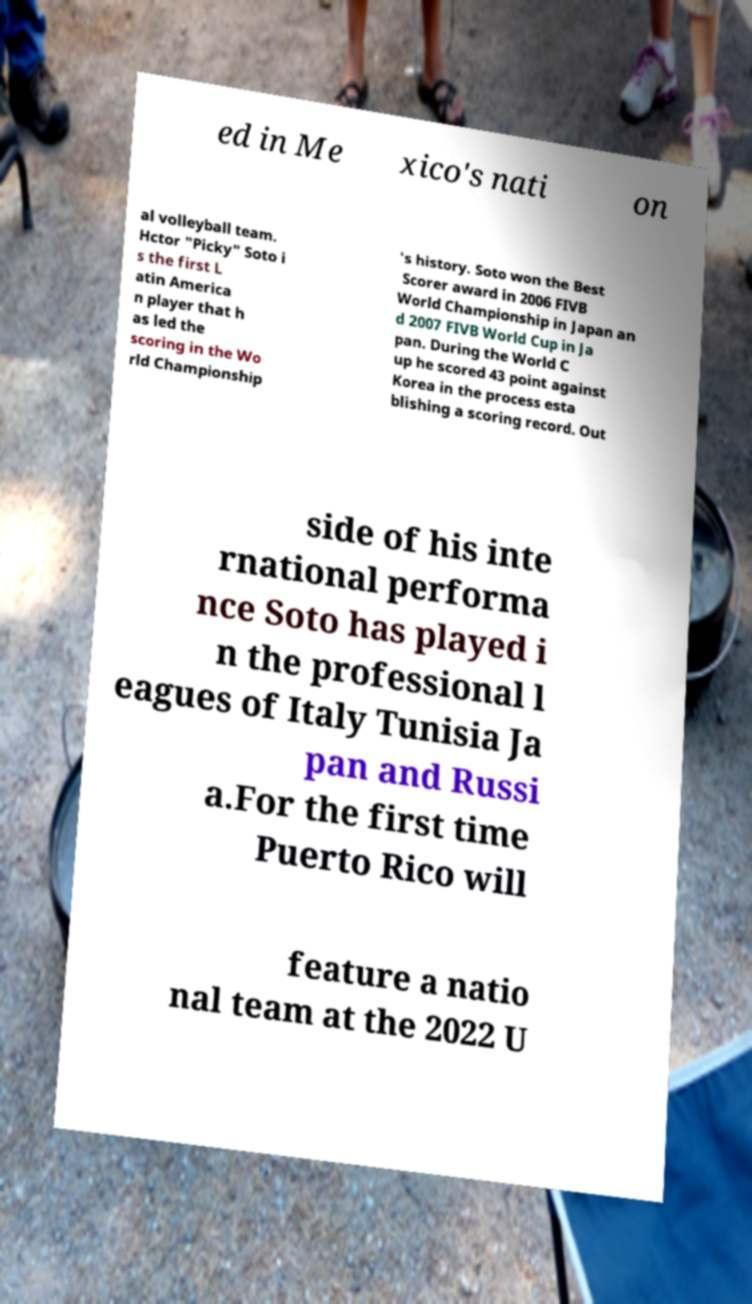Can you accurately transcribe the text from the provided image for me? ed in Me xico's nati on al volleyball team. Hctor "Picky" Soto i s the first L atin America n player that h as led the scoring in the Wo rld Championship 's history. Soto won the Best Scorer award in 2006 FIVB World Championship in Japan an d 2007 FIVB World Cup in Ja pan. During the World C up he scored 43 point against Korea in the process esta blishing a scoring record. Out side of his inte rnational performa nce Soto has played i n the professional l eagues of Italy Tunisia Ja pan and Russi a.For the first time Puerto Rico will feature a natio nal team at the 2022 U 